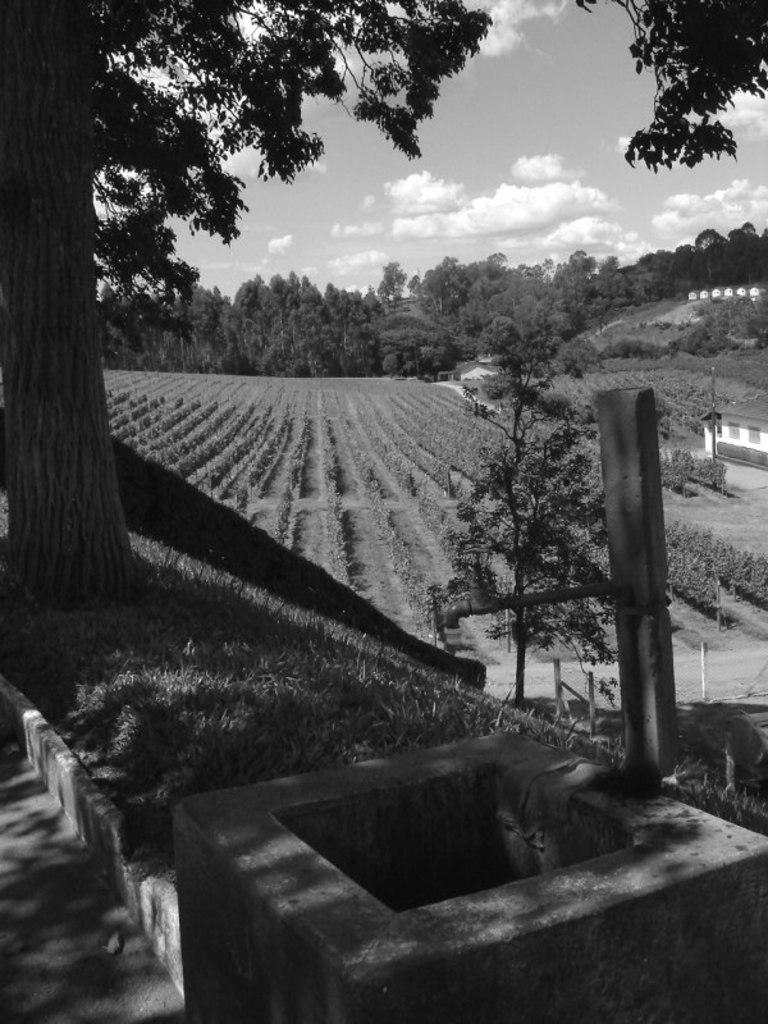Could you give a brief overview of what you see in this image? In front of the image there is a concrete structure. There are poles. There is grass on the surface. There are trees, plants, buildings. At the top of the image there are clouds in the sky. 